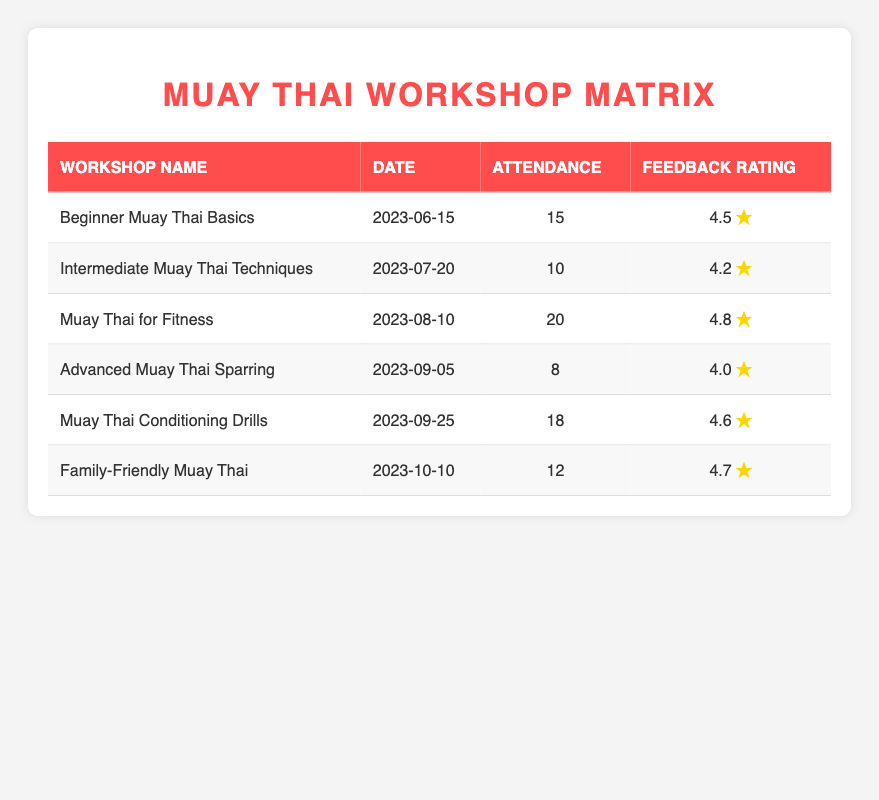What was the feedback rating for the "Muay Thai for Fitness" workshop? The table shows the feedback rating for each workshop. For "Muay Thai for Fitness," the feedback rating is listed as 4.8.
Answer: 4.8 Which workshop had the highest attendance? By comparing the attendance numbers in each row, "Muay Thai for Fitness" has the highest attendance at 20 participants.
Answer: Muay Thai for Fitness What is the average attendance for the workshops listed? The attendance values are 15, 10, 20, 8, 18, and 12. To get the average, we first sum these values: 15 + 10 + 20 + 8 + 18 + 12 = 83. There are 6 workshops, so the average attendance is 83 / 6 = 13.83.
Answer: 13.83 Did the "Advanced Muay Thai Sparring" workshop receive a feedback rating of 4 or higher? The feedback rating for the "Advanced Muay Thai Sparring" workshop is 4.0, which is equal to 4. Therefore, the statement is true.
Answer: Yes What is the difference in feedback rating between the "Beginner Muay Thai Basics" and "Intermediate Muay Thai Techniques" workshops? The feedback rating for "Beginner Muay Thai Basics" is 4.5 and for "Intermediate Muay Thai Techniques" it is 4.2. The difference is calculated as 4.5 - 4.2 = 0.3.
Answer: 0.3 How many workshops had an attendance of less than 15 participants? By examining the attendance column, "Intermediate Muay Thai Techniques" with 10 and "Advanced Muay Thai Sparring" with 8 have less than 15 participants. This amounts to 2 workshops.
Answer: 2 Which workshop had the best feedback rating, and what was it? The feedback ratings are: 4.5, 4.2, 4.8, 4.0, 4.6, and 4.7. The highest rating is 4.8, corresponding to the "Muay Thai for Fitness" workshop.
Answer: Muay Thai for Fitness, 4.8 How does the attendance of "Family-Friendly Muay Thai" compare to the average attendance of all workshops? The attendance for "Family-Friendly Muay Thai" is 12. The average attendance calculated previously is 13.83. Since 12 is less than 13.83, it shows the attendance is below average.
Answer: Below average 